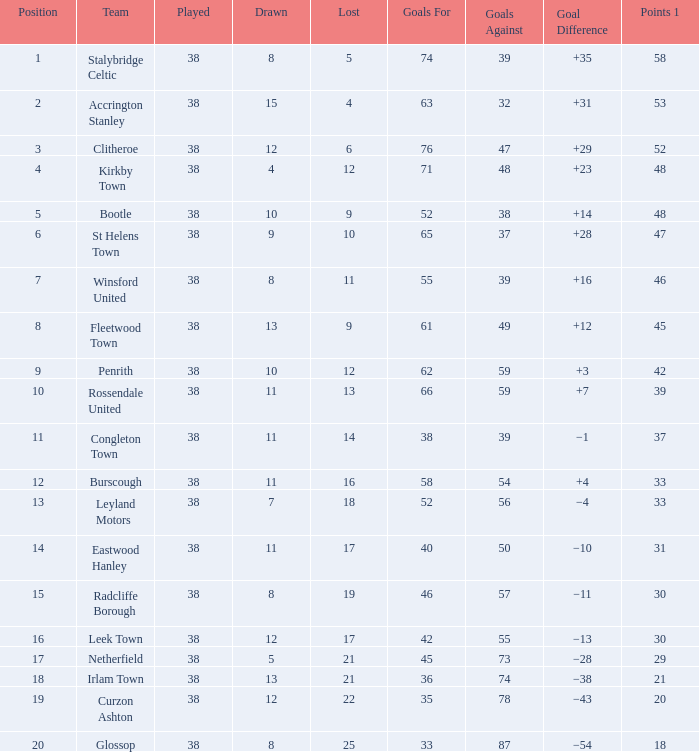What is the combined sum of goals that have taken place under 38 times? 0.0. 